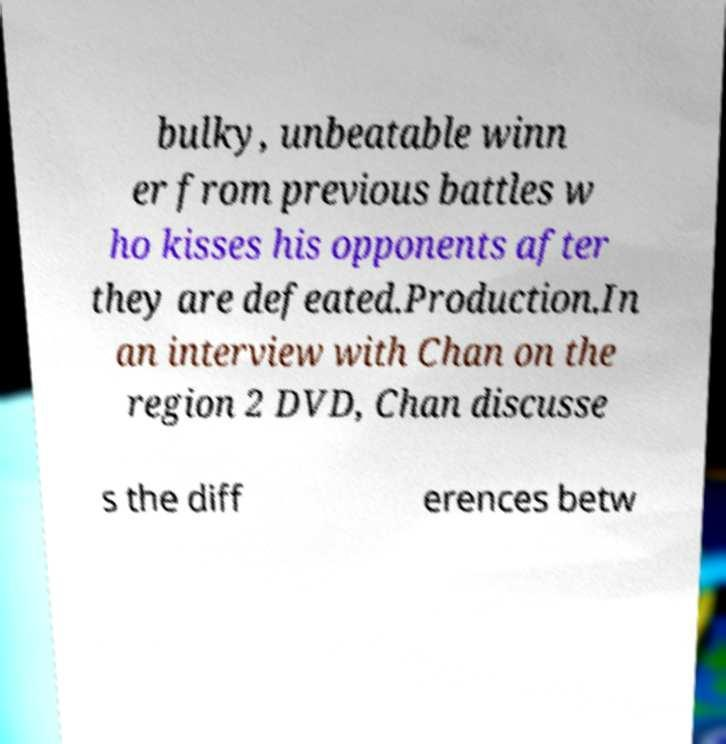There's text embedded in this image that I need extracted. Can you transcribe it verbatim? bulky, unbeatable winn er from previous battles w ho kisses his opponents after they are defeated.Production.In an interview with Chan on the region 2 DVD, Chan discusse s the diff erences betw 